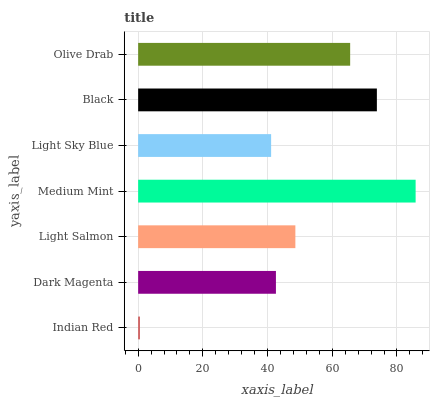Is Indian Red the minimum?
Answer yes or no. Yes. Is Medium Mint the maximum?
Answer yes or no. Yes. Is Dark Magenta the minimum?
Answer yes or no. No. Is Dark Magenta the maximum?
Answer yes or no. No. Is Dark Magenta greater than Indian Red?
Answer yes or no. Yes. Is Indian Red less than Dark Magenta?
Answer yes or no. Yes. Is Indian Red greater than Dark Magenta?
Answer yes or no. No. Is Dark Magenta less than Indian Red?
Answer yes or no. No. Is Light Salmon the high median?
Answer yes or no. Yes. Is Light Salmon the low median?
Answer yes or no. Yes. Is Light Sky Blue the high median?
Answer yes or no. No. Is Dark Magenta the low median?
Answer yes or no. No. 